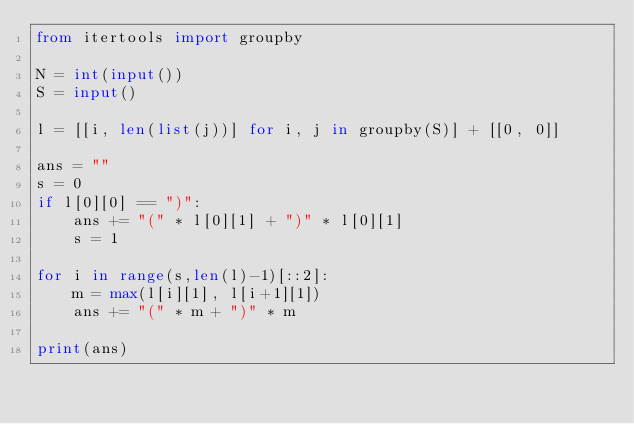Convert code to text. <code><loc_0><loc_0><loc_500><loc_500><_Python_>from itertools import groupby

N = int(input())
S = input()

l = [[i, len(list(j))] for i, j in groupby(S)] + [[0, 0]]

ans = ""
s = 0
if l[0][0] == ")":
    ans += "(" * l[0][1] + ")" * l[0][1]
    s = 1

for i in range(s,len(l)-1)[::2]:
    m = max(l[i][1], l[i+1][1])
    ans += "(" * m + ")" * m
    
print(ans)</code> 